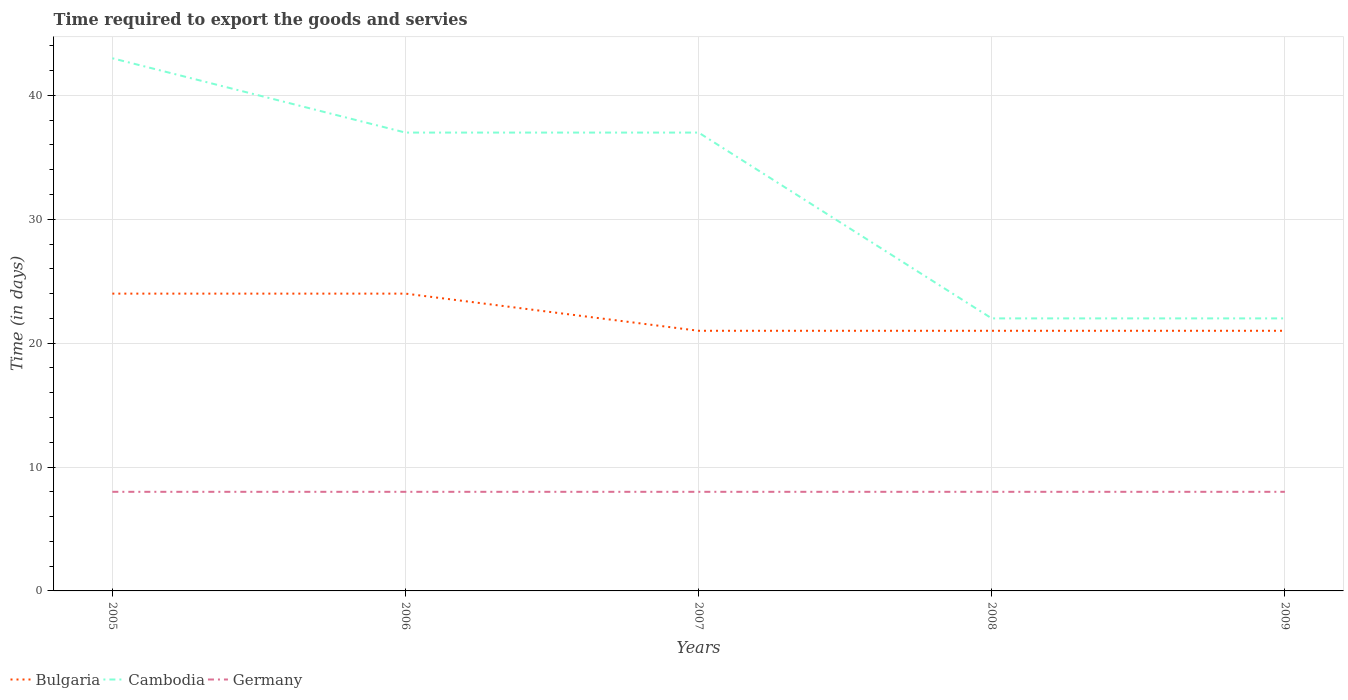How many different coloured lines are there?
Your answer should be compact. 3. Across all years, what is the maximum number of days required to export the goods and services in Germany?
Offer a very short reply. 8. In which year was the number of days required to export the goods and services in Germany maximum?
Give a very brief answer. 2005. What is the total number of days required to export the goods and services in Germany in the graph?
Your answer should be very brief. 0. What is the difference between the highest and the second highest number of days required to export the goods and services in Bulgaria?
Offer a very short reply. 3. What is the difference between the highest and the lowest number of days required to export the goods and services in Germany?
Provide a short and direct response. 0. Is the number of days required to export the goods and services in Germany strictly greater than the number of days required to export the goods and services in Bulgaria over the years?
Offer a very short reply. Yes. Are the values on the major ticks of Y-axis written in scientific E-notation?
Offer a terse response. No. How many legend labels are there?
Your response must be concise. 3. How are the legend labels stacked?
Ensure brevity in your answer.  Horizontal. What is the title of the graph?
Offer a very short reply. Time required to export the goods and servies. Does "Macao" appear as one of the legend labels in the graph?
Make the answer very short. No. What is the label or title of the Y-axis?
Your response must be concise. Time (in days). What is the Time (in days) of Germany in 2005?
Keep it short and to the point. 8. What is the Time (in days) in Germany in 2007?
Make the answer very short. 8. What is the Time (in days) of Cambodia in 2008?
Offer a terse response. 22. What is the Time (in days) of Germany in 2009?
Your answer should be very brief. 8. Across all years, what is the maximum Time (in days) of Bulgaria?
Make the answer very short. 24. Across all years, what is the maximum Time (in days) in Germany?
Your answer should be very brief. 8. Across all years, what is the minimum Time (in days) of Bulgaria?
Keep it short and to the point. 21. Across all years, what is the minimum Time (in days) in Cambodia?
Keep it short and to the point. 22. What is the total Time (in days) in Bulgaria in the graph?
Provide a succinct answer. 111. What is the total Time (in days) in Cambodia in the graph?
Ensure brevity in your answer.  161. What is the total Time (in days) in Germany in the graph?
Provide a short and direct response. 40. What is the difference between the Time (in days) of Germany in 2005 and that in 2006?
Your answer should be compact. 0. What is the difference between the Time (in days) in Bulgaria in 2005 and that in 2007?
Offer a very short reply. 3. What is the difference between the Time (in days) of Cambodia in 2005 and that in 2007?
Provide a succinct answer. 6. What is the difference between the Time (in days) in Germany in 2005 and that in 2007?
Provide a short and direct response. 0. What is the difference between the Time (in days) in Bulgaria in 2005 and that in 2008?
Your response must be concise. 3. What is the difference between the Time (in days) of Cambodia in 2005 and that in 2008?
Your answer should be very brief. 21. What is the difference between the Time (in days) in Bulgaria in 2006 and that in 2007?
Your response must be concise. 3. What is the difference between the Time (in days) of Germany in 2006 and that in 2008?
Make the answer very short. 0. What is the difference between the Time (in days) in Bulgaria in 2006 and that in 2009?
Offer a terse response. 3. What is the difference between the Time (in days) of Bulgaria in 2007 and that in 2008?
Ensure brevity in your answer.  0. What is the difference between the Time (in days) in Cambodia in 2007 and that in 2008?
Your answer should be very brief. 15. What is the difference between the Time (in days) of Germany in 2007 and that in 2008?
Your answer should be very brief. 0. What is the difference between the Time (in days) in Bulgaria in 2007 and that in 2009?
Offer a very short reply. 0. What is the difference between the Time (in days) of Germany in 2007 and that in 2009?
Offer a terse response. 0. What is the difference between the Time (in days) in Bulgaria in 2008 and that in 2009?
Make the answer very short. 0. What is the difference between the Time (in days) in Germany in 2008 and that in 2009?
Your answer should be compact. 0. What is the difference between the Time (in days) in Bulgaria in 2005 and the Time (in days) in Germany in 2006?
Your answer should be very brief. 16. What is the difference between the Time (in days) in Cambodia in 2005 and the Time (in days) in Germany in 2006?
Offer a terse response. 35. What is the difference between the Time (in days) of Bulgaria in 2005 and the Time (in days) of Cambodia in 2007?
Your answer should be compact. -13. What is the difference between the Time (in days) of Cambodia in 2005 and the Time (in days) of Germany in 2007?
Ensure brevity in your answer.  35. What is the difference between the Time (in days) of Bulgaria in 2005 and the Time (in days) of Cambodia in 2008?
Offer a terse response. 2. What is the difference between the Time (in days) of Bulgaria in 2005 and the Time (in days) of Germany in 2008?
Your response must be concise. 16. What is the difference between the Time (in days) in Bulgaria in 2006 and the Time (in days) in Cambodia in 2007?
Keep it short and to the point. -13. What is the difference between the Time (in days) in Cambodia in 2006 and the Time (in days) in Germany in 2007?
Your answer should be very brief. 29. What is the difference between the Time (in days) of Bulgaria in 2006 and the Time (in days) of Germany in 2008?
Give a very brief answer. 16. What is the difference between the Time (in days) in Cambodia in 2006 and the Time (in days) in Germany in 2008?
Your answer should be compact. 29. What is the difference between the Time (in days) in Cambodia in 2006 and the Time (in days) in Germany in 2009?
Provide a short and direct response. 29. What is the difference between the Time (in days) in Bulgaria in 2007 and the Time (in days) in Cambodia in 2008?
Provide a short and direct response. -1. What is the difference between the Time (in days) in Bulgaria in 2007 and the Time (in days) in Germany in 2008?
Your response must be concise. 13. What is the difference between the Time (in days) in Bulgaria in 2007 and the Time (in days) in Germany in 2009?
Ensure brevity in your answer.  13. What is the average Time (in days) of Bulgaria per year?
Make the answer very short. 22.2. What is the average Time (in days) in Cambodia per year?
Your response must be concise. 32.2. In the year 2005, what is the difference between the Time (in days) of Bulgaria and Time (in days) of Cambodia?
Give a very brief answer. -19. In the year 2005, what is the difference between the Time (in days) of Bulgaria and Time (in days) of Germany?
Provide a succinct answer. 16. In the year 2006, what is the difference between the Time (in days) of Bulgaria and Time (in days) of Cambodia?
Make the answer very short. -13. In the year 2006, what is the difference between the Time (in days) in Cambodia and Time (in days) in Germany?
Provide a succinct answer. 29. In the year 2007, what is the difference between the Time (in days) in Bulgaria and Time (in days) in Cambodia?
Offer a terse response. -16. In the year 2007, what is the difference between the Time (in days) of Bulgaria and Time (in days) of Germany?
Offer a terse response. 13. In the year 2008, what is the difference between the Time (in days) in Bulgaria and Time (in days) in Cambodia?
Offer a very short reply. -1. In the year 2009, what is the difference between the Time (in days) of Cambodia and Time (in days) of Germany?
Provide a short and direct response. 14. What is the ratio of the Time (in days) in Bulgaria in 2005 to that in 2006?
Make the answer very short. 1. What is the ratio of the Time (in days) of Cambodia in 2005 to that in 2006?
Make the answer very short. 1.16. What is the ratio of the Time (in days) in Bulgaria in 2005 to that in 2007?
Provide a succinct answer. 1.14. What is the ratio of the Time (in days) of Cambodia in 2005 to that in 2007?
Your response must be concise. 1.16. What is the ratio of the Time (in days) of Germany in 2005 to that in 2007?
Your answer should be compact. 1. What is the ratio of the Time (in days) of Bulgaria in 2005 to that in 2008?
Your response must be concise. 1.14. What is the ratio of the Time (in days) in Cambodia in 2005 to that in 2008?
Give a very brief answer. 1.95. What is the ratio of the Time (in days) in Germany in 2005 to that in 2008?
Provide a short and direct response. 1. What is the ratio of the Time (in days) of Bulgaria in 2005 to that in 2009?
Ensure brevity in your answer.  1.14. What is the ratio of the Time (in days) of Cambodia in 2005 to that in 2009?
Your answer should be compact. 1.95. What is the ratio of the Time (in days) in Bulgaria in 2006 to that in 2007?
Give a very brief answer. 1.14. What is the ratio of the Time (in days) in Germany in 2006 to that in 2007?
Ensure brevity in your answer.  1. What is the ratio of the Time (in days) in Cambodia in 2006 to that in 2008?
Your answer should be compact. 1.68. What is the ratio of the Time (in days) in Bulgaria in 2006 to that in 2009?
Ensure brevity in your answer.  1.14. What is the ratio of the Time (in days) of Cambodia in 2006 to that in 2009?
Provide a short and direct response. 1.68. What is the ratio of the Time (in days) in Cambodia in 2007 to that in 2008?
Provide a succinct answer. 1.68. What is the ratio of the Time (in days) in Bulgaria in 2007 to that in 2009?
Your response must be concise. 1. What is the ratio of the Time (in days) in Cambodia in 2007 to that in 2009?
Give a very brief answer. 1.68. What is the ratio of the Time (in days) in Cambodia in 2008 to that in 2009?
Provide a succinct answer. 1. What is the ratio of the Time (in days) in Germany in 2008 to that in 2009?
Provide a short and direct response. 1. What is the difference between the highest and the second highest Time (in days) of Cambodia?
Offer a terse response. 6. What is the difference between the highest and the lowest Time (in days) of Cambodia?
Your answer should be very brief. 21. 